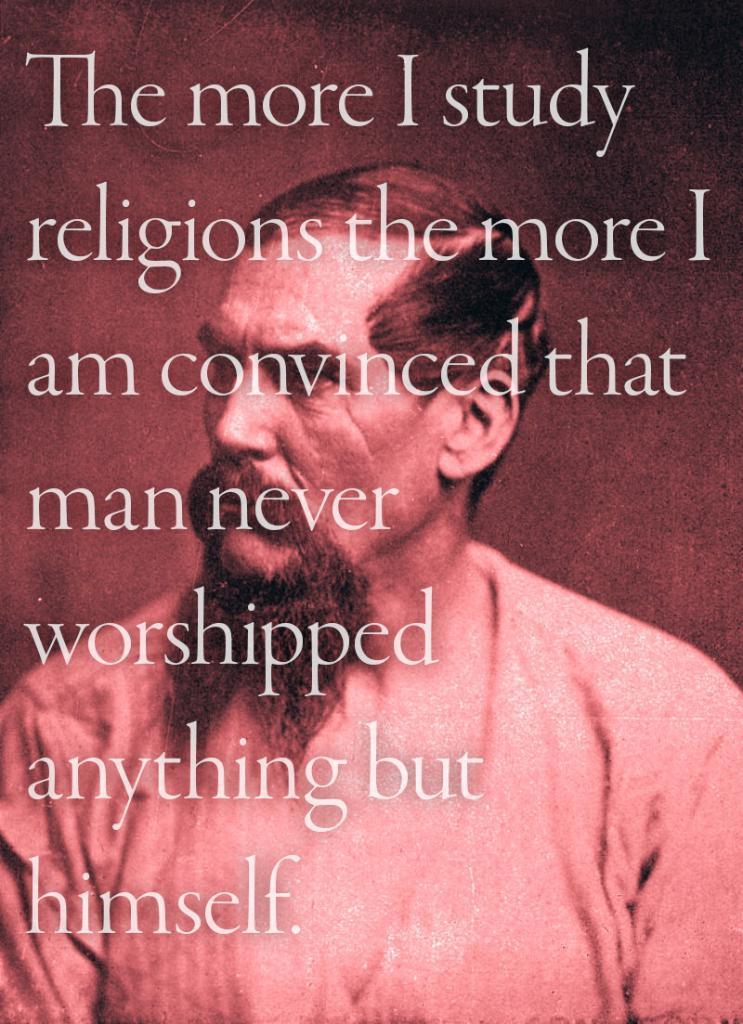In one or two sentences, can you explain what this image depicts? This is a poster and in this poster we can see a man and some text. 